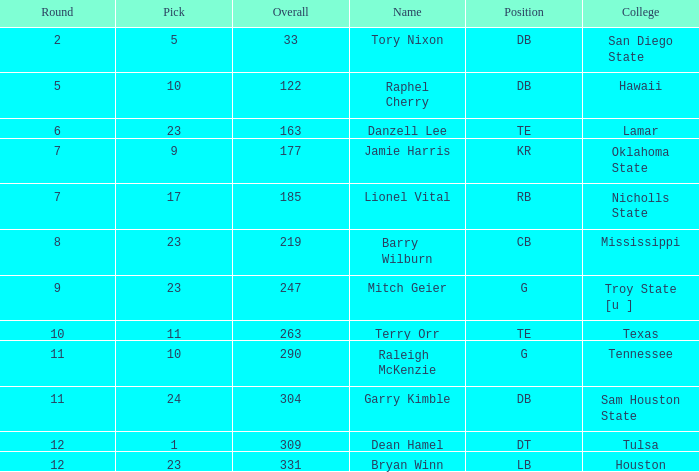How many Picks have an Overall smaller than 304, and a Position of g, and a Round smaller than 11? 1.0. 